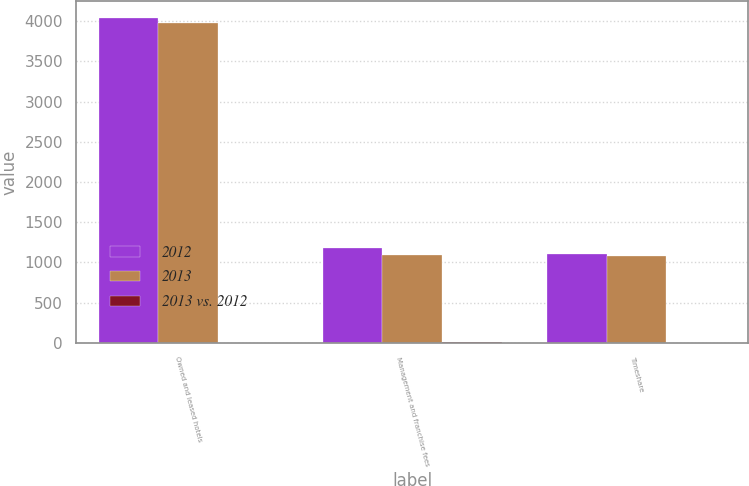Convert chart. <chart><loc_0><loc_0><loc_500><loc_500><stacked_bar_chart><ecel><fcel>Owned and leased hotels<fcel>Management and franchise fees<fcel>Timeshare<nl><fcel>2012<fcel>4046<fcel>1175<fcel>1109<nl><fcel>2013<fcel>3979<fcel>1088<fcel>1085<nl><fcel>2013 vs. 2012<fcel>1.7<fcel>8<fcel>2.2<nl></chart> 